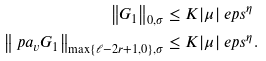<formula> <loc_0><loc_0><loc_500><loc_500>\left \| G _ { 1 } \right \| _ { 0 , \sigma } & \leq K | \mu | \ e p s ^ { \eta } \\ \left \| \ p a _ { v } G _ { 1 } \right \| _ { \max \{ \ell - 2 r + 1 , 0 \} , \sigma } & \leq K | \mu | \ e p s ^ { \eta } .</formula> 